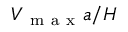<formula> <loc_0><loc_0><loc_500><loc_500>V _ { m a x } a / H</formula> 